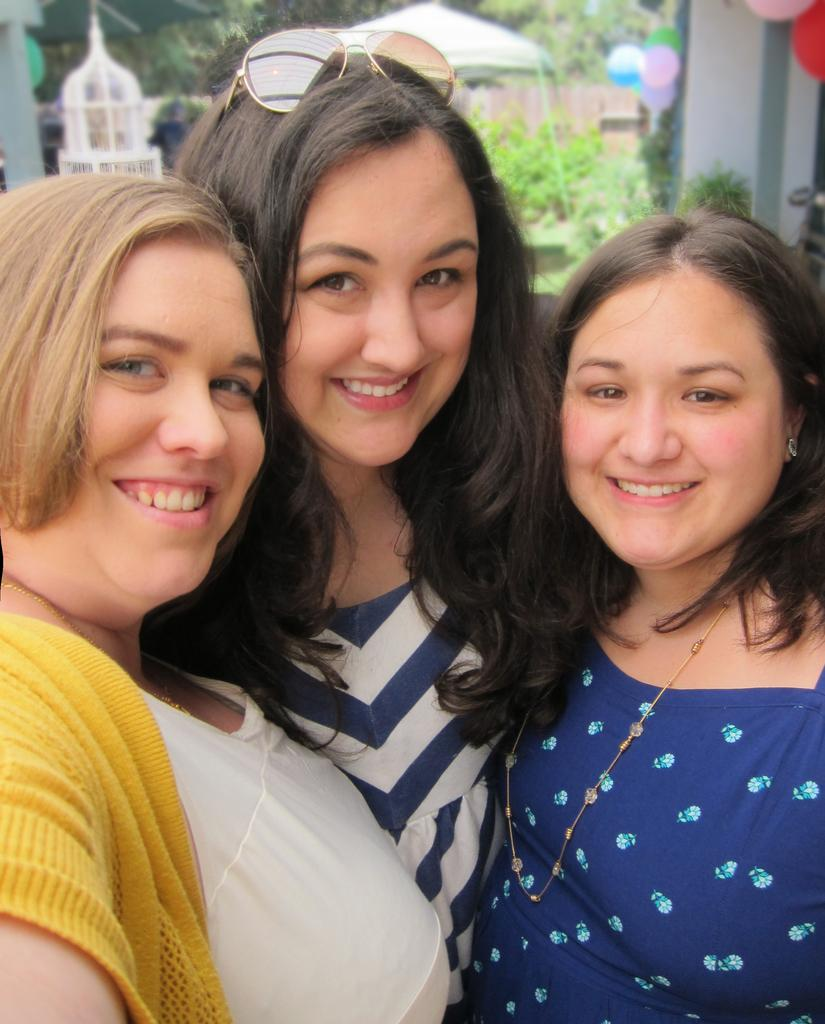How many women are present in the image? There are three women in the image. What is the facial expression of the women? The women are smiling. Can you describe the background of the image? The background of the image is blurred. What type of structures can be seen in the image? There are tents in the image. What type of vegetation is present in the image? There are plants and trees in the image. What additional objects can be seen in the image? There are balloons in the image. What type of grape is being held by the beast in the image? There is no beast or grape present in the image. 